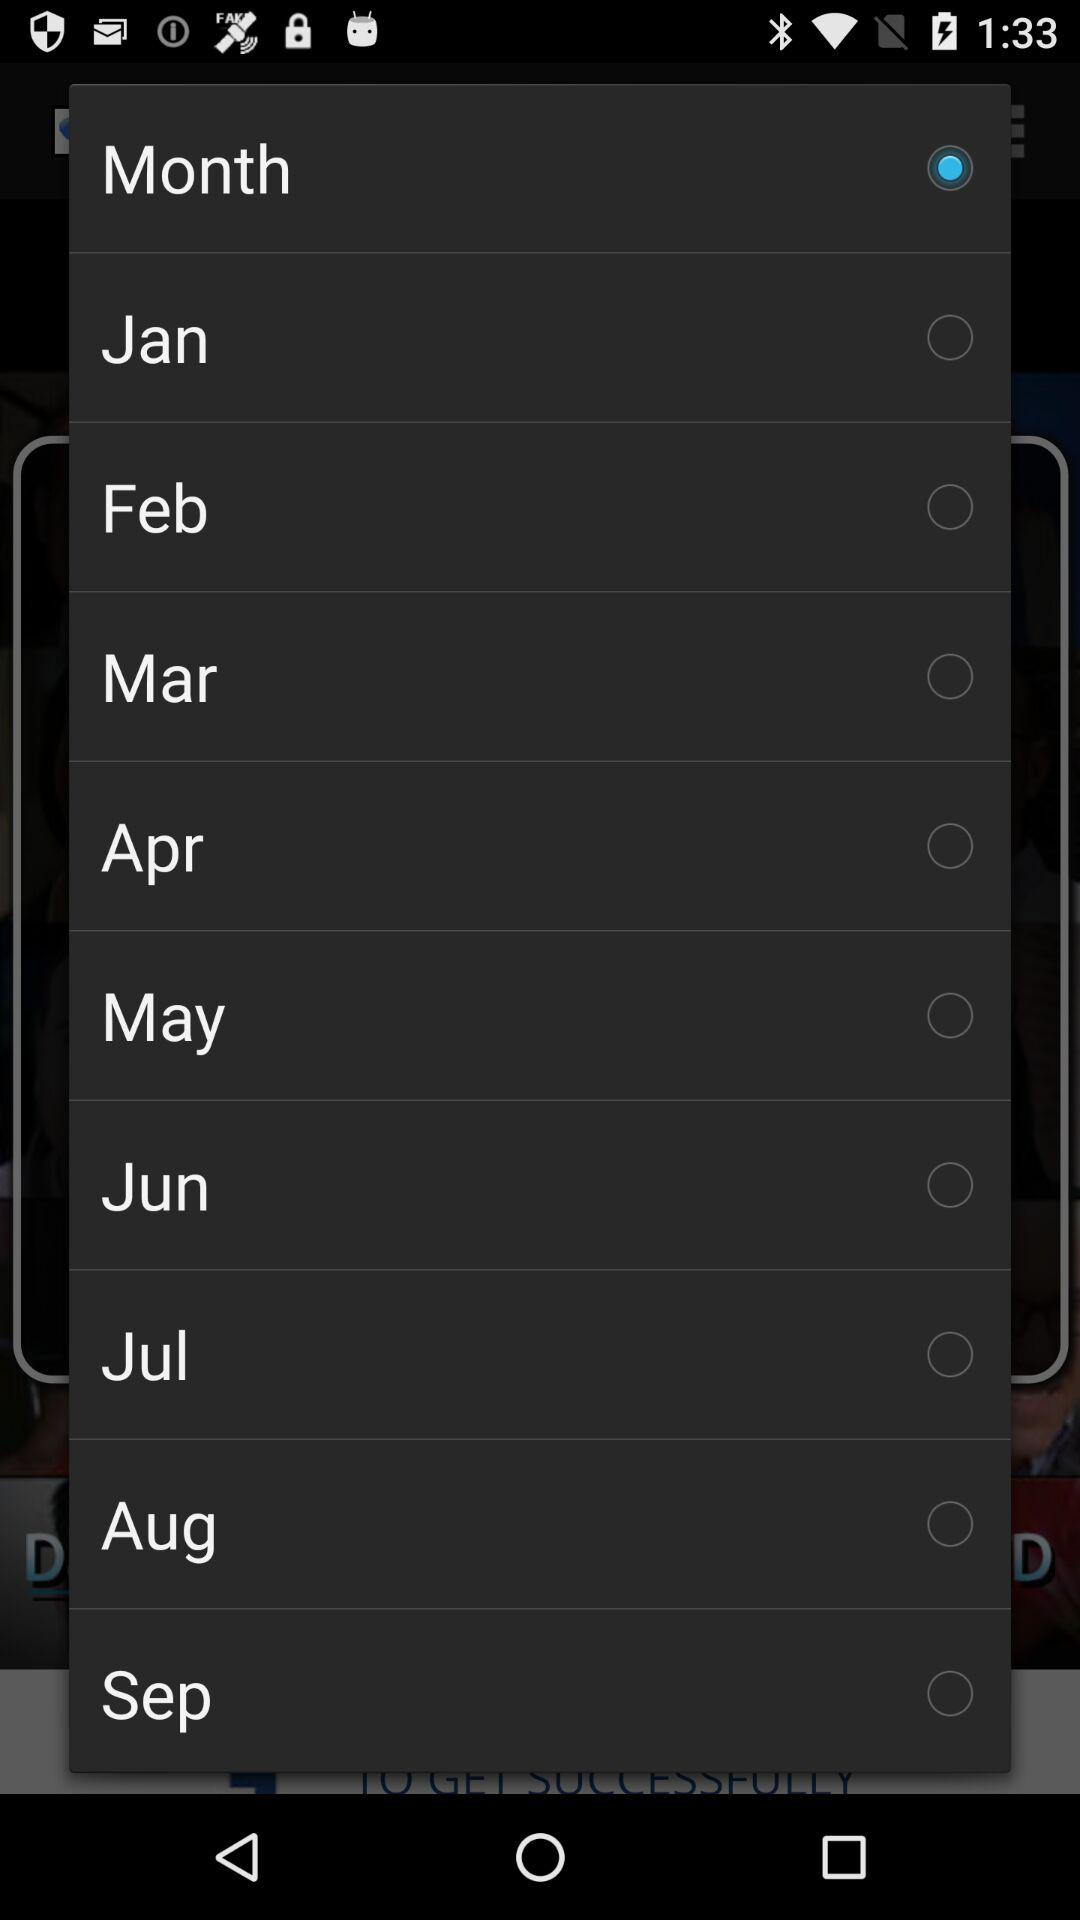What is the status of the month? The status is "on". 